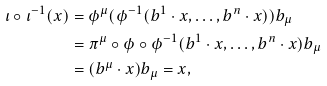<formula> <loc_0><loc_0><loc_500><loc_500>\iota \circ \iota ^ { - 1 } ( x ) & = \phi ^ { \mu } ( \phi ^ { - 1 } ( b ^ { 1 } \cdot x , \dots , b ^ { n } \cdot x ) ) b _ { \mu } \\ & = \pi ^ { \mu } \circ \phi \circ \phi ^ { - 1 } ( b ^ { 1 } \cdot x , \dots , b ^ { n } \cdot x ) b _ { \mu } \\ & = ( b ^ { \mu } \cdot x ) b _ { \mu } = x ,</formula> 